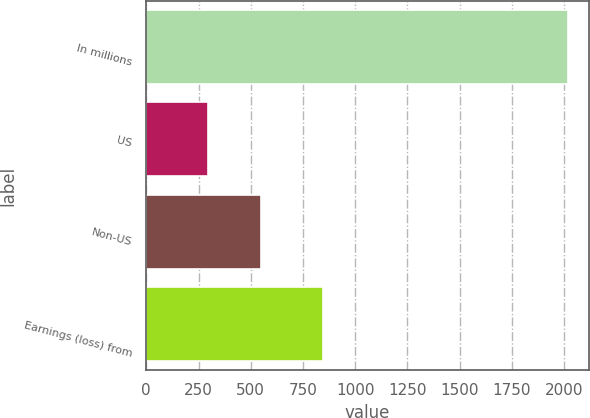Convert chart to OTSL. <chart><loc_0><loc_0><loc_500><loc_500><bar_chart><fcel>In millions<fcel>US<fcel>Non-US<fcel>Earnings (loss) from<nl><fcel>2017<fcel>297<fcel>551<fcel>848<nl></chart> 